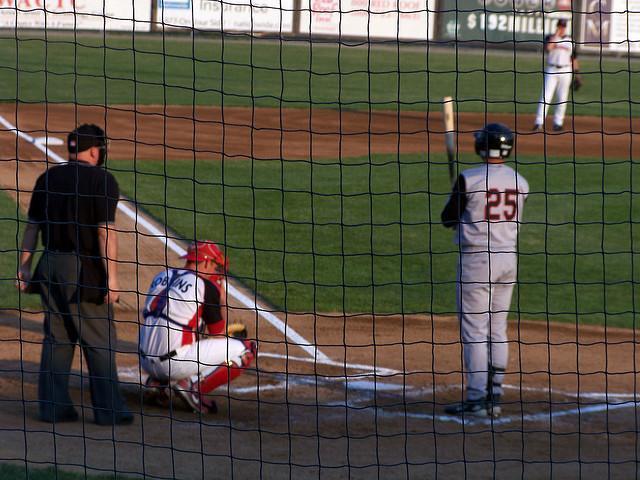How many people are there?
Give a very brief answer. 4. How many baby elephants are there?
Give a very brief answer. 0. 